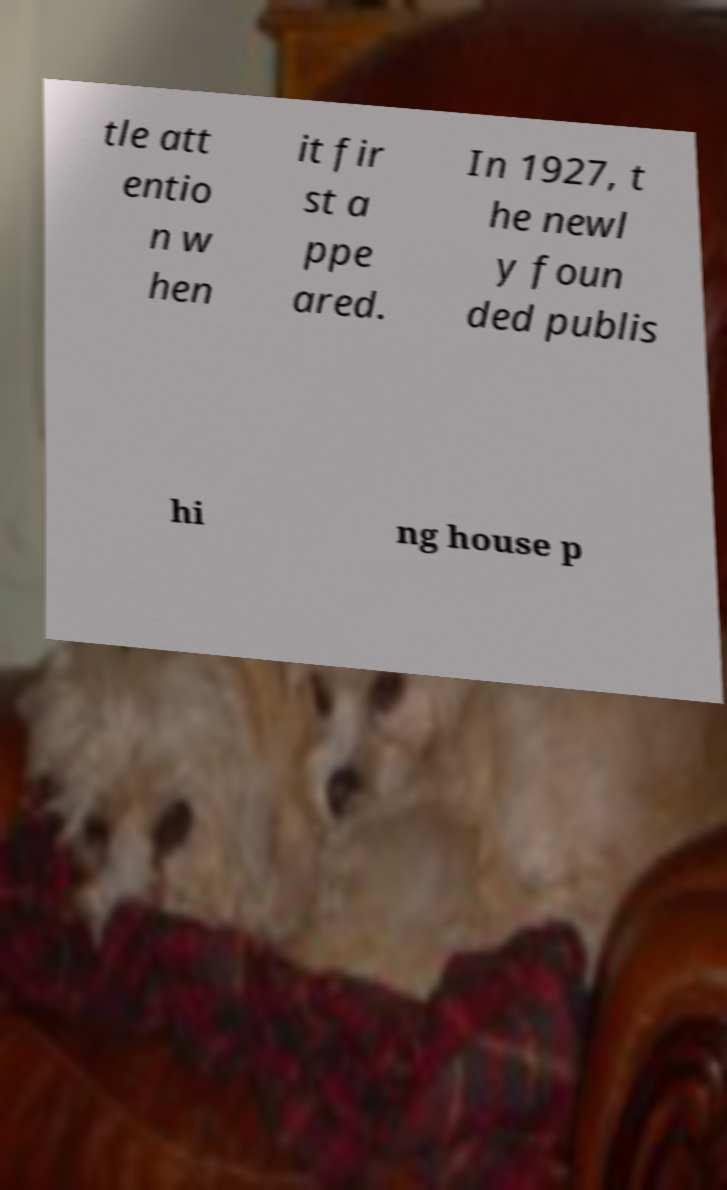For documentation purposes, I need the text within this image transcribed. Could you provide that? tle att entio n w hen it fir st a ppe ared. In 1927, t he newl y foun ded publis hi ng house p 